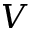<formula> <loc_0><loc_0><loc_500><loc_500>V</formula> 